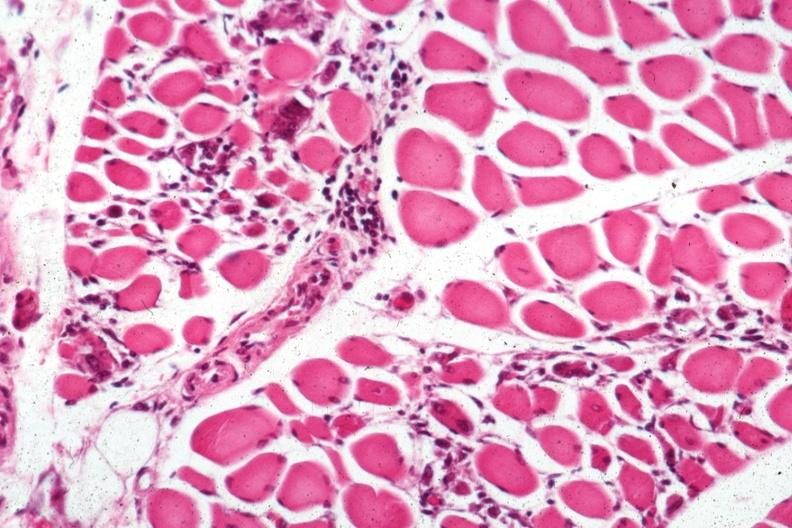does this image show small lymphorrhages?
Answer the question using a single word or phrase. Yes 